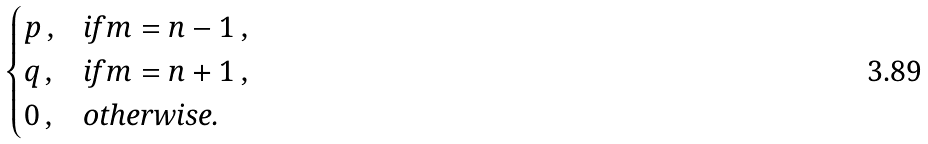<formula> <loc_0><loc_0><loc_500><loc_500>\begin{cases} p \, , & \text {if} \, m = n - 1 \, , \\ q \, , & \text {if} \, m = n + 1 \, , \\ 0 \, , & \text {otherwise.} \\ \end{cases}</formula> 